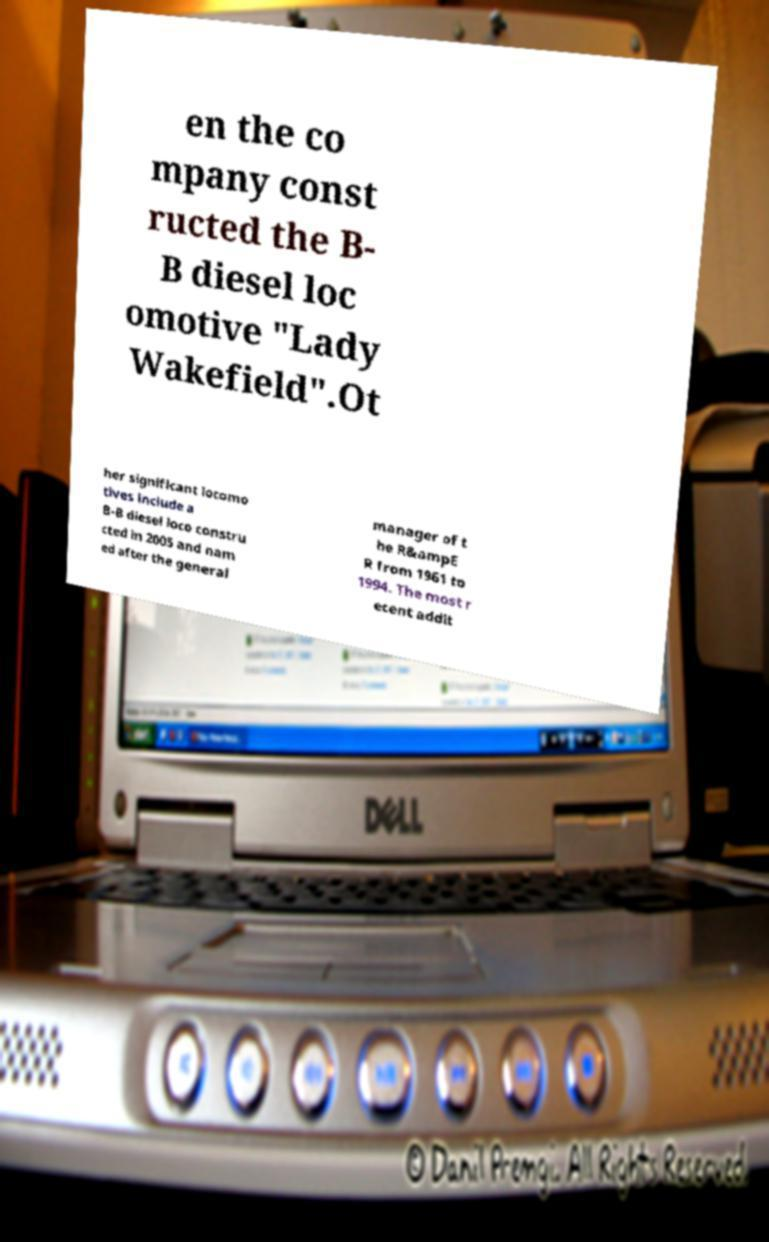Please identify and transcribe the text found in this image. en the co mpany const ructed the B- B diesel loc omotive "Lady Wakefield".Ot her significant locomo tives include a B-B diesel loco constru cted in 2005 and nam ed after the general manager of t he R&ampE R from 1961 to 1994. The most r ecent addit 